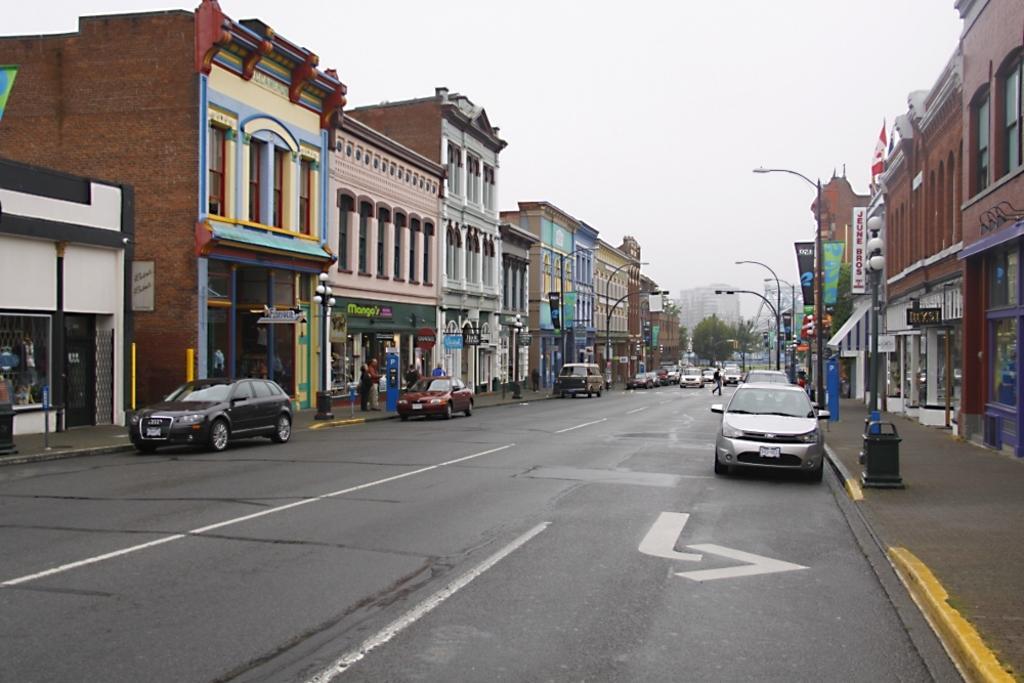Describe this image in one or two sentences. There is a road. On the road there are vehicles. On the sides of the road there are sidewalks. On the sidewalks there are street light poles. Also there are buildings with name boards, pillars. In the background there are trees and sky. 